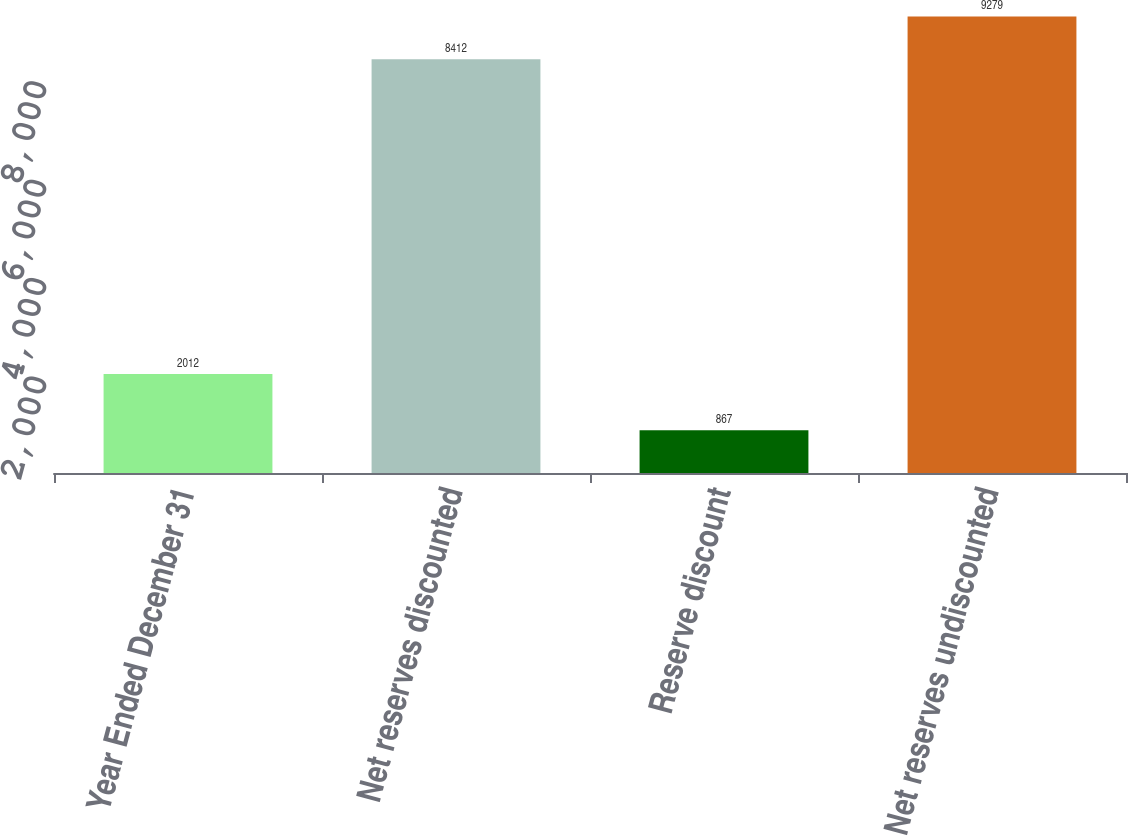Convert chart to OTSL. <chart><loc_0><loc_0><loc_500><loc_500><bar_chart><fcel>Year Ended December 31<fcel>Net reserves discounted<fcel>Reserve discount<fcel>Net reserves undiscounted<nl><fcel>2012<fcel>8412<fcel>867<fcel>9279<nl></chart> 